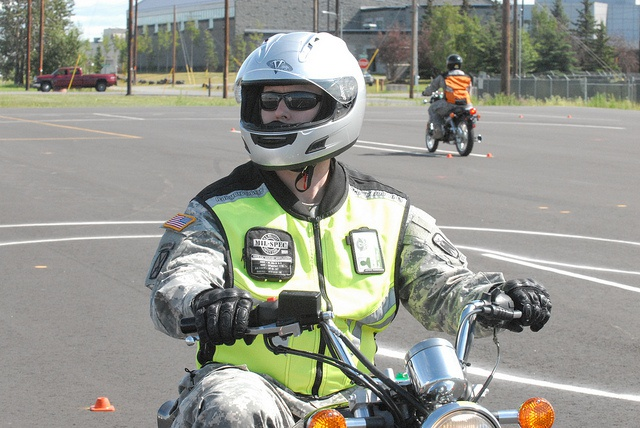Describe the objects in this image and their specific colors. I can see people in gray, white, darkgray, and black tones, motorcycle in gray, black, darkgray, and white tones, people in gray, black, orange, and darkgray tones, motorcycle in gray, black, darkgray, and lightgray tones, and truck in gray, black, and purple tones in this image. 